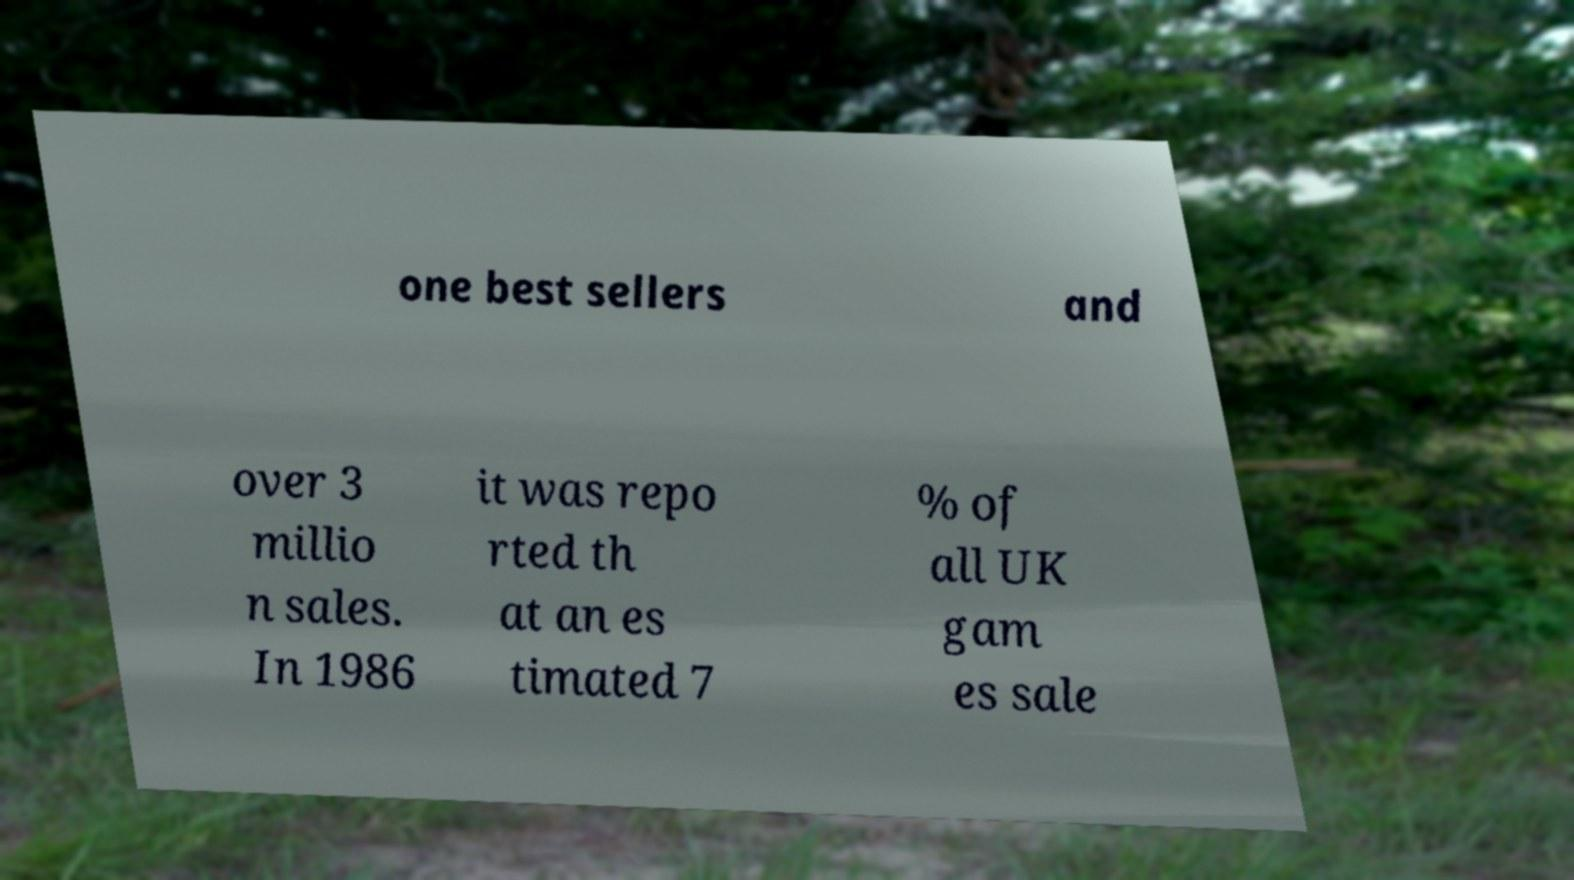Can you accurately transcribe the text from the provided image for me? one best sellers and over 3 millio n sales. In 1986 it was repo rted th at an es timated 7 % of all UK gam es sale 